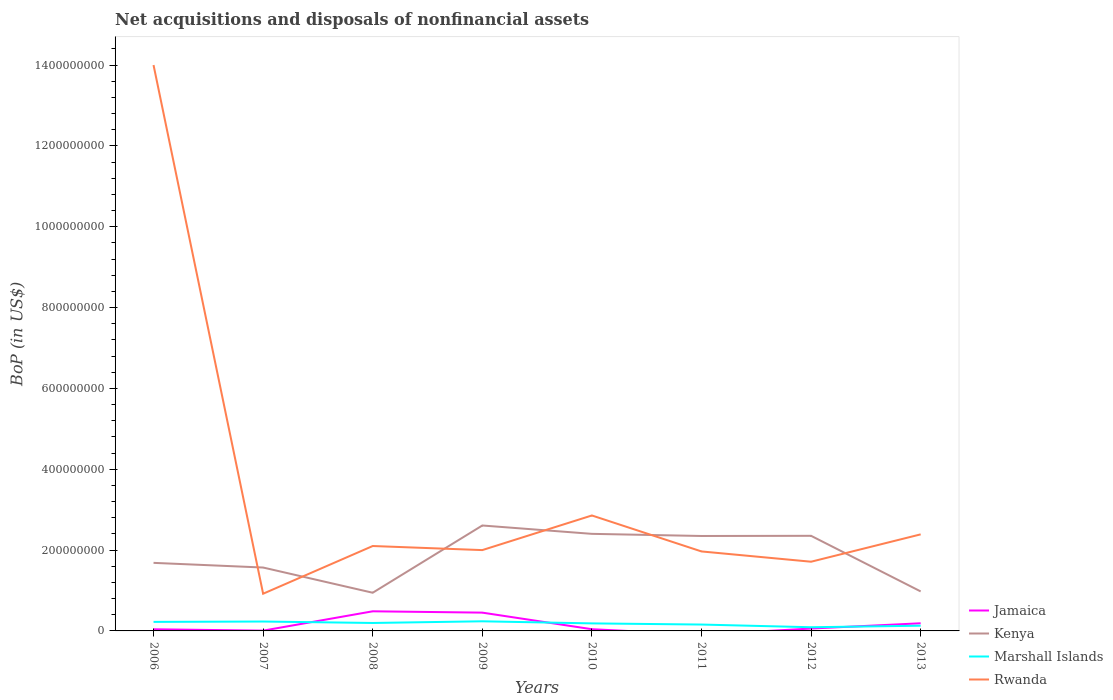How many different coloured lines are there?
Provide a succinct answer. 4. Is the number of lines equal to the number of legend labels?
Provide a succinct answer. No. Across all years, what is the maximum Balance of Payments in Marshall Islands?
Your response must be concise. 9.14e+06. What is the total Balance of Payments in Jamaica in the graph?
Keep it short and to the point. -4.12e+07. What is the difference between the highest and the second highest Balance of Payments in Kenya?
Your response must be concise. 1.66e+08. What is the difference between the highest and the lowest Balance of Payments in Jamaica?
Your answer should be compact. 3. Is the Balance of Payments in Marshall Islands strictly greater than the Balance of Payments in Rwanda over the years?
Keep it short and to the point. Yes. Are the values on the major ticks of Y-axis written in scientific E-notation?
Keep it short and to the point. No. Does the graph contain grids?
Your response must be concise. No. Where does the legend appear in the graph?
Provide a succinct answer. Bottom right. How many legend labels are there?
Offer a very short reply. 4. What is the title of the graph?
Make the answer very short. Net acquisitions and disposals of nonfinancial assets. What is the label or title of the X-axis?
Give a very brief answer. Years. What is the label or title of the Y-axis?
Your answer should be compact. BoP (in US$). What is the BoP (in US$) in Jamaica in 2006?
Your answer should be compact. 4.09e+06. What is the BoP (in US$) in Kenya in 2006?
Make the answer very short. 1.68e+08. What is the BoP (in US$) in Marshall Islands in 2006?
Your response must be concise. 2.23e+07. What is the BoP (in US$) in Rwanda in 2006?
Provide a short and direct response. 1.40e+09. What is the BoP (in US$) of Jamaica in 2007?
Provide a short and direct response. 6.90e+05. What is the BoP (in US$) in Kenya in 2007?
Your response must be concise. 1.57e+08. What is the BoP (in US$) of Marshall Islands in 2007?
Provide a short and direct response. 2.32e+07. What is the BoP (in US$) of Rwanda in 2007?
Offer a very short reply. 9.20e+07. What is the BoP (in US$) of Jamaica in 2008?
Your answer should be compact. 4.86e+07. What is the BoP (in US$) in Kenya in 2008?
Your answer should be very brief. 9.45e+07. What is the BoP (in US$) of Marshall Islands in 2008?
Your response must be concise. 1.97e+07. What is the BoP (in US$) in Rwanda in 2008?
Your answer should be very brief. 2.10e+08. What is the BoP (in US$) of Jamaica in 2009?
Your answer should be compact. 4.53e+07. What is the BoP (in US$) of Kenya in 2009?
Offer a terse response. 2.61e+08. What is the BoP (in US$) in Marshall Islands in 2009?
Provide a short and direct response. 2.38e+07. What is the BoP (in US$) in Rwanda in 2009?
Your response must be concise. 2.00e+08. What is the BoP (in US$) of Jamaica in 2010?
Make the answer very short. 4.24e+06. What is the BoP (in US$) in Kenya in 2010?
Offer a terse response. 2.40e+08. What is the BoP (in US$) of Marshall Islands in 2010?
Give a very brief answer. 1.86e+07. What is the BoP (in US$) of Rwanda in 2010?
Provide a succinct answer. 2.86e+08. What is the BoP (in US$) in Jamaica in 2011?
Your response must be concise. 0. What is the BoP (in US$) of Kenya in 2011?
Provide a succinct answer. 2.35e+08. What is the BoP (in US$) of Marshall Islands in 2011?
Make the answer very short. 1.58e+07. What is the BoP (in US$) in Rwanda in 2011?
Provide a short and direct response. 1.97e+08. What is the BoP (in US$) in Jamaica in 2012?
Ensure brevity in your answer.  5.87e+06. What is the BoP (in US$) in Kenya in 2012?
Offer a very short reply. 2.35e+08. What is the BoP (in US$) in Marshall Islands in 2012?
Give a very brief answer. 9.14e+06. What is the BoP (in US$) of Rwanda in 2012?
Provide a succinct answer. 1.71e+08. What is the BoP (in US$) in Jamaica in 2013?
Ensure brevity in your answer.  1.89e+07. What is the BoP (in US$) of Kenya in 2013?
Your response must be concise. 9.77e+07. What is the BoP (in US$) of Marshall Islands in 2013?
Provide a short and direct response. 1.29e+07. What is the BoP (in US$) of Rwanda in 2013?
Ensure brevity in your answer.  2.39e+08. Across all years, what is the maximum BoP (in US$) in Jamaica?
Your answer should be compact. 4.86e+07. Across all years, what is the maximum BoP (in US$) in Kenya?
Provide a short and direct response. 2.61e+08. Across all years, what is the maximum BoP (in US$) in Marshall Islands?
Provide a short and direct response. 2.38e+07. Across all years, what is the maximum BoP (in US$) in Rwanda?
Your answer should be compact. 1.40e+09. Across all years, what is the minimum BoP (in US$) in Kenya?
Provide a short and direct response. 9.45e+07. Across all years, what is the minimum BoP (in US$) of Marshall Islands?
Ensure brevity in your answer.  9.14e+06. Across all years, what is the minimum BoP (in US$) in Rwanda?
Ensure brevity in your answer.  9.20e+07. What is the total BoP (in US$) of Jamaica in the graph?
Give a very brief answer. 1.28e+08. What is the total BoP (in US$) in Kenya in the graph?
Ensure brevity in your answer.  1.49e+09. What is the total BoP (in US$) of Marshall Islands in the graph?
Make the answer very short. 1.46e+08. What is the total BoP (in US$) of Rwanda in the graph?
Your answer should be very brief. 2.79e+09. What is the difference between the BoP (in US$) of Jamaica in 2006 and that in 2007?
Offer a terse response. 3.40e+06. What is the difference between the BoP (in US$) in Kenya in 2006 and that in 2007?
Offer a very short reply. 1.16e+07. What is the difference between the BoP (in US$) in Marshall Islands in 2006 and that in 2007?
Offer a very short reply. -9.06e+05. What is the difference between the BoP (in US$) in Rwanda in 2006 and that in 2007?
Make the answer very short. 1.31e+09. What is the difference between the BoP (in US$) of Jamaica in 2006 and that in 2008?
Provide a succinct answer. -4.45e+07. What is the difference between the BoP (in US$) of Kenya in 2006 and that in 2008?
Offer a terse response. 7.39e+07. What is the difference between the BoP (in US$) of Marshall Islands in 2006 and that in 2008?
Provide a succinct answer. 2.67e+06. What is the difference between the BoP (in US$) of Rwanda in 2006 and that in 2008?
Provide a succinct answer. 1.19e+09. What is the difference between the BoP (in US$) in Jamaica in 2006 and that in 2009?
Make the answer very short. -4.12e+07. What is the difference between the BoP (in US$) in Kenya in 2006 and that in 2009?
Offer a terse response. -9.25e+07. What is the difference between the BoP (in US$) in Marshall Islands in 2006 and that in 2009?
Your answer should be very brief. -1.47e+06. What is the difference between the BoP (in US$) in Rwanda in 2006 and that in 2009?
Give a very brief answer. 1.20e+09. What is the difference between the BoP (in US$) of Jamaica in 2006 and that in 2010?
Your response must be concise. -1.52e+05. What is the difference between the BoP (in US$) of Kenya in 2006 and that in 2010?
Give a very brief answer. -7.18e+07. What is the difference between the BoP (in US$) in Marshall Islands in 2006 and that in 2010?
Provide a short and direct response. 3.70e+06. What is the difference between the BoP (in US$) of Rwanda in 2006 and that in 2010?
Give a very brief answer. 1.11e+09. What is the difference between the BoP (in US$) in Kenya in 2006 and that in 2011?
Provide a short and direct response. -6.65e+07. What is the difference between the BoP (in US$) in Marshall Islands in 2006 and that in 2011?
Offer a very short reply. 6.58e+06. What is the difference between the BoP (in US$) in Rwanda in 2006 and that in 2011?
Ensure brevity in your answer.  1.20e+09. What is the difference between the BoP (in US$) in Jamaica in 2006 and that in 2012?
Offer a very short reply. -1.78e+06. What is the difference between the BoP (in US$) in Kenya in 2006 and that in 2012?
Keep it short and to the point. -6.69e+07. What is the difference between the BoP (in US$) in Marshall Islands in 2006 and that in 2012?
Make the answer very short. 1.32e+07. What is the difference between the BoP (in US$) in Rwanda in 2006 and that in 2012?
Give a very brief answer. 1.23e+09. What is the difference between the BoP (in US$) in Jamaica in 2006 and that in 2013?
Make the answer very short. -1.48e+07. What is the difference between the BoP (in US$) of Kenya in 2006 and that in 2013?
Provide a short and direct response. 7.07e+07. What is the difference between the BoP (in US$) of Marshall Islands in 2006 and that in 2013?
Offer a terse response. 9.43e+06. What is the difference between the BoP (in US$) of Rwanda in 2006 and that in 2013?
Your answer should be very brief. 1.16e+09. What is the difference between the BoP (in US$) in Jamaica in 2007 and that in 2008?
Your response must be concise. -4.79e+07. What is the difference between the BoP (in US$) in Kenya in 2007 and that in 2008?
Ensure brevity in your answer.  6.24e+07. What is the difference between the BoP (in US$) in Marshall Islands in 2007 and that in 2008?
Keep it short and to the point. 3.57e+06. What is the difference between the BoP (in US$) in Rwanda in 2007 and that in 2008?
Your response must be concise. -1.18e+08. What is the difference between the BoP (in US$) of Jamaica in 2007 and that in 2009?
Provide a short and direct response. -4.46e+07. What is the difference between the BoP (in US$) of Kenya in 2007 and that in 2009?
Your response must be concise. -1.04e+08. What is the difference between the BoP (in US$) in Marshall Islands in 2007 and that in 2009?
Your response must be concise. -5.65e+05. What is the difference between the BoP (in US$) of Rwanda in 2007 and that in 2009?
Your answer should be very brief. -1.08e+08. What is the difference between the BoP (in US$) in Jamaica in 2007 and that in 2010?
Your answer should be compact. -3.55e+06. What is the difference between the BoP (in US$) in Kenya in 2007 and that in 2010?
Your answer should be very brief. -8.33e+07. What is the difference between the BoP (in US$) in Marshall Islands in 2007 and that in 2010?
Offer a very short reply. 4.61e+06. What is the difference between the BoP (in US$) of Rwanda in 2007 and that in 2010?
Offer a terse response. -1.94e+08. What is the difference between the BoP (in US$) of Kenya in 2007 and that in 2011?
Keep it short and to the point. -7.81e+07. What is the difference between the BoP (in US$) in Marshall Islands in 2007 and that in 2011?
Your response must be concise. 7.48e+06. What is the difference between the BoP (in US$) in Rwanda in 2007 and that in 2011?
Ensure brevity in your answer.  -1.05e+08. What is the difference between the BoP (in US$) in Jamaica in 2007 and that in 2012?
Your answer should be compact. -5.18e+06. What is the difference between the BoP (in US$) of Kenya in 2007 and that in 2012?
Make the answer very short. -7.85e+07. What is the difference between the BoP (in US$) of Marshall Islands in 2007 and that in 2012?
Provide a short and direct response. 1.41e+07. What is the difference between the BoP (in US$) of Rwanda in 2007 and that in 2012?
Offer a very short reply. -7.92e+07. What is the difference between the BoP (in US$) of Jamaica in 2007 and that in 2013?
Ensure brevity in your answer.  -1.82e+07. What is the difference between the BoP (in US$) in Kenya in 2007 and that in 2013?
Your answer should be compact. 5.91e+07. What is the difference between the BoP (in US$) in Marshall Islands in 2007 and that in 2013?
Provide a short and direct response. 1.03e+07. What is the difference between the BoP (in US$) of Rwanda in 2007 and that in 2013?
Your response must be concise. -1.47e+08. What is the difference between the BoP (in US$) of Jamaica in 2008 and that in 2009?
Offer a very short reply. 3.31e+06. What is the difference between the BoP (in US$) of Kenya in 2008 and that in 2009?
Your response must be concise. -1.66e+08. What is the difference between the BoP (in US$) in Marshall Islands in 2008 and that in 2009?
Ensure brevity in your answer.  -4.14e+06. What is the difference between the BoP (in US$) in Rwanda in 2008 and that in 2009?
Ensure brevity in your answer.  1.01e+07. What is the difference between the BoP (in US$) of Jamaica in 2008 and that in 2010?
Ensure brevity in your answer.  4.43e+07. What is the difference between the BoP (in US$) of Kenya in 2008 and that in 2010?
Your answer should be compact. -1.46e+08. What is the difference between the BoP (in US$) of Marshall Islands in 2008 and that in 2010?
Give a very brief answer. 1.04e+06. What is the difference between the BoP (in US$) in Rwanda in 2008 and that in 2010?
Make the answer very short. -7.56e+07. What is the difference between the BoP (in US$) of Kenya in 2008 and that in 2011?
Keep it short and to the point. -1.40e+08. What is the difference between the BoP (in US$) in Marshall Islands in 2008 and that in 2011?
Provide a short and direct response. 3.91e+06. What is the difference between the BoP (in US$) of Rwanda in 2008 and that in 2011?
Your answer should be very brief. 1.34e+07. What is the difference between the BoP (in US$) in Jamaica in 2008 and that in 2012?
Your answer should be very brief. 4.27e+07. What is the difference between the BoP (in US$) of Kenya in 2008 and that in 2012?
Your answer should be compact. -1.41e+08. What is the difference between the BoP (in US$) of Marshall Islands in 2008 and that in 2012?
Provide a succinct answer. 1.05e+07. What is the difference between the BoP (in US$) in Rwanda in 2008 and that in 2012?
Your response must be concise. 3.88e+07. What is the difference between the BoP (in US$) of Jamaica in 2008 and that in 2013?
Provide a short and direct response. 2.97e+07. What is the difference between the BoP (in US$) in Kenya in 2008 and that in 2013?
Offer a terse response. -3.26e+06. What is the difference between the BoP (in US$) in Marshall Islands in 2008 and that in 2013?
Give a very brief answer. 6.76e+06. What is the difference between the BoP (in US$) in Rwanda in 2008 and that in 2013?
Ensure brevity in your answer.  -2.89e+07. What is the difference between the BoP (in US$) of Jamaica in 2009 and that in 2010?
Offer a very short reply. 4.10e+07. What is the difference between the BoP (in US$) of Kenya in 2009 and that in 2010?
Offer a terse response. 2.07e+07. What is the difference between the BoP (in US$) of Marshall Islands in 2009 and that in 2010?
Your answer should be very brief. 5.17e+06. What is the difference between the BoP (in US$) in Rwanda in 2009 and that in 2010?
Provide a short and direct response. -8.56e+07. What is the difference between the BoP (in US$) of Kenya in 2009 and that in 2011?
Your response must be concise. 2.60e+07. What is the difference between the BoP (in US$) of Marshall Islands in 2009 and that in 2011?
Provide a short and direct response. 8.05e+06. What is the difference between the BoP (in US$) in Rwanda in 2009 and that in 2011?
Offer a very short reply. 3.34e+06. What is the difference between the BoP (in US$) of Jamaica in 2009 and that in 2012?
Offer a terse response. 3.94e+07. What is the difference between the BoP (in US$) of Kenya in 2009 and that in 2012?
Keep it short and to the point. 2.56e+07. What is the difference between the BoP (in US$) in Marshall Islands in 2009 and that in 2012?
Keep it short and to the point. 1.47e+07. What is the difference between the BoP (in US$) in Rwanda in 2009 and that in 2012?
Offer a very short reply. 2.88e+07. What is the difference between the BoP (in US$) in Jamaica in 2009 and that in 2013?
Provide a short and direct response. 2.64e+07. What is the difference between the BoP (in US$) of Kenya in 2009 and that in 2013?
Offer a terse response. 1.63e+08. What is the difference between the BoP (in US$) of Marshall Islands in 2009 and that in 2013?
Keep it short and to the point. 1.09e+07. What is the difference between the BoP (in US$) in Rwanda in 2009 and that in 2013?
Provide a succinct answer. -3.89e+07. What is the difference between the BoP (in US$) in Kenya in 2010 and that in 2011?
Give a very brief answer. 5.29e+06. What is the difference between the BoP (in US$) of Marshall Islands in 2010 and that in 2011?
Provide a short and direct response. 2.88e+06. What is the difference between the BoP (in US$) in Rwanda in 2010 and that in 2011?
Make the answer very short. 8.90e+07. What is the difference between the BoP (in US$) of Jamaica in 2010 and that in 2012?
Give a very brief answer. -1.63e+06. What is the difference between the BoP (in US$) in Kenya in 2010 and that in 2012?
Your response must be concise. 4.88e+06. What is the difference between the BoP (in US$) of Marshall Islands in 2010 and that in 2012?
Ensure brevity in your answer.  9.50e+06. What is the difference between the BoP (in US$) of Rwanda in 2010 and that in 2012?
Keep it short and to the point. 1.14e+08. What is the difference between the BoP (in US$) of Jamaica in 2010 and that in 2013?
Give a very brief answer. -1.47e+07. What is the difference between the BoP (in US$) in Kenya in 2010 and that in 2013?
Give a very brief answer. 1.42e+08. What is the difference between the BoP (in US$) of Marshall Islands in 2010 and that in 2013?
Your answer should be very brief. 5.73e+06. What is the difference between the BoP (in US$) of Rwanda in 2010 and that in 2013?
Your response must be concise. 4.67e+07. What is the difference between the BoP (in US$) in Kenya in 2011 and that in 2012?
Give a very brief answer. -4.11e+05. What is the difference between the BoP (in US$) of Marshall Islands in 2011 and that in 2012?
Provide a short and direct response. 6.62e+06. What is the difference between the BoP (in US$) of Rwanda in 2011 and that in 2012?
Keep it short and to the point. 2.54e+07. What is the difference between the BoP (in US$) in Kenya in 2011 and that in 2013?
Your answer should be compact. 1.37e+08. What is the difference between the BoP (in US$) in Marshall Islands in 2011 and that in 2013?
Keep it short and to the point. 2.85e+06. What is the difference between the BoP (in US$) in Rwanda in 2011 and that in 2013?
Provide a succinct answer. -4.23e+07. What is the difference between the BoP (in US$) of Jamaica in 2012 and that in 2013?
Keep it short and to the point. -1.30e+07. What is the difference between the BoP (in US$) of Kenya in 2012 and that in 2013?
Provide a succinct answer. 1.38e+08. What is the difference between the BoP (in US$) in Marshall Islands in 2012 and that in 2013?
Your answer should be compact. -3.77e+06. What is the difference between the BoP (in US$) of Rwanda in 2012 and that in 2013?
Provide a short and direct response. -6.77e+07. What is the difference between the BoP (in US$) of Jamaica in 2006 and the BoP (in US$) of Kenya in 2007?
Your answer should be very brief. -1.53e+08. What is the difference between the BoP (in US$) of Jamaica in 2006 and the BoP (in US$) of Marshall Islands in 2007?
Ensure brevity in your answer.  -1.92e+07. What is the difference between the BoP (in US$) in Jamaica in 2006 and the BoP (in US$) in Rwanda in 2007?
Your response must be concise. -8.79e+07. What is the difference between the BoP (in US$) of Kenya in 2006 and the BoP (in US$) of Marshall Islands in 2007?
Ensure brevity in your answer.  1.45e+08. What is the difference between the BoP (in US$) of Kenya in 2006 and the BoP (in US$) of Rwanda in 2007?
Your answer should be compact. 7.64e+07. What is the difference between the BoP (in US$) in Marshall Islands in 2006 and the BoP (in US$) in Rwanda in 2007?
Ensure brevity in your answer.  -6.97e+07. What is the difference between the BoP (in US$) in Jamaica in 2006 and the BoP (in US$) in Kenya in 2008?
Make the answer very short. -9.04e+07. What is the difference between the BoP (in US$) of Jamaica in 2006 and the BoP (in US$) of Marshall Islands in 2008?
Offer a very short reply. -1.56e+07. What is the difference between the BoP (in US$) of Jamaica in 2006 and the BoP (in US$) of Rwanda in 2008?
Provide a succinct answer. -2.06e+08. What is the difference between the BoP (in US$) of Kenya in 2006 and the BoP (in US$) of Marshall Islands in 2008?
Keep it short and to the point. 1.49e+08. What is the difference between the BoP (in US$) in Kenya in 2006 and the BoP (in US$) in Rwanda in 2008?
Offer a very short reply. -4.17e+07. What is the difference between the BoP (in US$) in Marshall Islands in 2006 and the BoP (in US$) in Rwanda in 2008?
Keep it short and to the point. -1.88e+08. What is the difference between the BoP (in US$) in Jamaica in 2006 and the BoP (in US$) in Kenya in 2009?
Offer a very short reply. -2.57e+08. What is the difference between the BoP (in US$) of Jamaica in 2006 and the BoP (in US$) of Marshall Islands in 2009?
Ensure brevity in your answer.  -1.97e+07. What is the difference between the BoP (in US$) in Jamaica in 2006 and the BoP (in US$) in Rwanda in 2009?
Provide a short and direct response. -1.96e+08. What is the difference between the BoP (in US$) in Kenya in 2006 and the BoP (in US$) in Marshall Islands in 2009?
Make the answer very short. 1.45e+08. What is the difference between the BoP (in US$) in Kenya in 2006 and the BoP (in US$) in Rwanda in 2009?
Your response must be concise. -3.16e+07. What is the difference between the BoP (in US$) of Marshall Islands in 2006 and the BoP (in US$) of Rwanda in 2009?
Offer a terse response. -1.78e+08. What is the difference between the BoP (in US$) in Jamaica in 2006 and the BoP (in US$) in Kenya in 2010?
Your answer should be very brief. -2.36e+08. What is the difference between the BoP (in US$) in Jamaica in 2006 and the BoP (in US$) in Marshall Islands in 2010?
Your response must be concise. -1.45e+07. What is the difference between the BoP (in US$) of Jamaica in 2006 and the BoP (in US$) of Rwanda in 2010?
Offer a terse response. -2.82e+08. What is the difference between the BoP (in US$) in Kenya in 2006 and the BoP (in US$) in Marshall Islands in 2010?
Your answer should be very brief. 1.50e+08. What is the difference between the BoP (in US$) of Kenya in 2006 and the BoP (in US$) of Rwanda in 2010?
Provide a short and direct response. -1.17e+08. What is the difference between the BoP (in US$) in Marshall Islands in 2006 and the BoP (in US$) in Rwanda in 2010?
Provide a short and direct response. -2.63e+08. What is the difference between the BoP (in US$) of Jamaica in 2006 and the BoP (in US$) of Kenya in 2011?
Give a very brief answer. -2.31e+08. What is the difference between the BoP (in US$) in Jamaica in 2006 and the BoP (in US$) in Marshall Islands in 2011?
Keep it short and to the point. -1.17e+07. What is the difference between the BoP (in US$) of Jamaica in 2006 and the BoP (in US$) of Rwanda in 2011?
Your answer should be compact. -1.93e+08. What is the difference between the BoP (in US$) in Kenya in 2006 and the BoP (in US$) in Marshall Islands in 2011?
Offer a terse response. 1.53e+08. What is the difference between the BoP (in US$) of Kenya in 2006 and the BoP (in US$) of Rwanda in 2011?
Offer a very short reply. -2.83e+07. What is the difference between the BoP (in US$) of Marshall Islands in 2006 and the BoP (in US$) of Rwanda in 2011?
Provide a succinct answer. -1.74e+08. What is the difference between the BoP (in US$) of Jamaica in 2006 and the BoP (in US$) of Kenya in 2012?
Give a very brief answer. -2.31e+08. What is the difference between the BoP (in US$) of Jamaica in 2006 and the BoP (in US$) of Marshall Islands in 2012?
Provide a short and direct response. -5.05e+06. What is the difference between the BoP (in US$) in Jamaica in 2006 and the BoP (in US$) in Rwanda in 2012?
Offer a terse response. -1.67e+08. What is the difference between the BoP (in US$) in Kenya in 2006 and the BoP (in US$) in Marshall Islands in 2012?
Offer a very short reply. 1.59e+08. What is the difference between the BoP (in US$) in Kenya in 2006 and the BoP (in US$) in Rwanda in 2012?
Give a very brief answer. -2.82e+06. What is the difference between the BoP (in US$) in Marshall Islands in 2006 and the BoP (in US$) in Rwanda in 2012?
Offer a terse response. -1.49e+08. What is the difference between the BoP (in US$) in Jamaica in 2006 and the BoP (in US$) in Kenya in 2013?
Offer a terse response. -9.36e+07. What is the difference between the BoP (in US$) of Jamaica in 2006 and the BoP (in US$) of Marshall Islands in 2013?
Keep it short and to the point. -8.82e+06. What is the difference between the BoP (in US$) of Jamaica in 2006 and the BoP (in US$) of Rwanda in 2013?
Give a very brief answer. -2.35e+08. What is the difference between the BoP (in US$) in Kenya in 2006 and the BoP (in US$) in Marshall Islands in 2013?
Offer a very short reply. 1.55e+08. What is the difference between the BoP (in US$) in Kenya in 2006 and the BoP (in US$) in Rwanda in 2013?
Ensure brevity in your answer.  -7.05e+07. What is the difference between the BoP (in US$) of Marshall Islands in 2006 and the BoP (in US$) of Rwanda in 2013?
Your answer should be compact. -2.17e+08. What is the difference between the BoP (in US$) in Jamaica in 2007 and the BoP (in US$) in Kenya in 2008?
Give a very brief answer. -9.38e+07. What is the difference between the BoP (in US$) of Jamaica in 2007 and the BoP (in US$) of Marshall Islands in 2008?
Ensure brevity in your answer.  -1.90e+07. What is the difference between the BoP (in US$) of Jamaica in 2007 and the BoP (in US$) of Rwanda in 2008?
Your response must be concise. -2.09e+08. What is the difference between the BoP (in US$) in Kenya in 2007 and the BoP (in US$) in Marshall Islands in 2008?
Your answer should be very brief. 1.37e+08. What is the difference between the BoP (in US$) of Kenya in 2007 and the BoP (in US$) of Rwanda in 2008?
Your answer should be compact. -5.32e+07. What is the difference between the BoP (in US$) of Marshall Islands in 2007 and the BoP (in US$) of Rwanda in 2008?
Ensure brevity in your answer.  -1.87e+08. What is the difference between the BoP (in US$) in Jamaica in 2007 and the BoP (in US$) in Kenya in 2009?
Your answer should be very brief. -2.60e+08. What is the difference between the BoP (in US$) in Jamaica in 2007 and the BoP (in US$) in Marshall Islands in 2009?
Give a very brief answer. -2.31e+07. What is the difference between the BoP (in US$) of Jamaica in 2007 and the BoP (in US$) of Rwanda in 2009?
Provide a succinct answer. -1.99e+08. What is the difference between the BoP (in US$) of Kenya in 2007 and the BoP (in US$) of Marshall Islands in 2009?
Offer a terse response. 1.33e+08. What is the difference between the BoP (in US$) of Kenya in 2007 and the BoP (in US$) of Rwanda in 2009?
Keep it short and to the point. -4.32e+07. What is the difference between the BoP (in US$) of Marshall Islands in 2007 and the BoP (in US$) of Rwanda in 2009?
Provide a succinct answer. -1.77e+08. What is the difference between the BoP (in US$) of Jamaica in 2007 and the BoP (in US$) of Kenya in 2010?
Make the answer very short. -2.39e+08. What is the difference between the BoP (in US$) of Jamaica in 2007 and the BoP (in US$) of Marshall Islands in 2010?
Offer a very short reply. -1.79e+07. What is the difference between the BoP (in US$) in Jamaica in 2007 and the BoP (in US$) in Rwanda in 2010?
Keep it short and to the point. -2.85e+08. What is the difference between the BoP (in US$) in Kenya in 2007 and the BoP (in US$) in Marshall Islands in 2010?
Offer a very short reply. 1.38e+08. What is the difference between the BoP (in US$) in Kenya in 2007 and the BoP (in US$) in Rwanda in 2010?
Provide a short and direct response. -1.29e+08. What is the difference between the BoP (in US$) of Marshall Islands in 2007 and the BoP (in US$) of Rwanda in 2010?
Your answer should be compact. -2.62e+08. What is the difference between the BoP (in US$) of Jamaica in 2007 and the BoP (in US$) of Kenya in 2011?
Make the answer very short. -2.34e+08. What is the difference between the BoP (in US$) in Jamaica in 2007 and the BoP (in US$) in Marshall Islands in 2011?
Your answer should be compact. -1.51e+07. What is the difference between the BoP (in US$) in Jamaica in 2007 and the BoP (in US$) in Rwanda in 2011?
Provide a short and direct response. -1.96e+08. What is the difference between the BoP (in US$) of Kenya in 2007 and the BoP (in US$) of Marshall Islands in 2011?
Keep it short and to the point. 1.41e+08. What is the difference between the BoP (in US$) of Kenya in 2007 and the BoP (in US$) of Rwanda in 2011?
Make the answer very short. -3.98e+07. What is the difference between the BoP (in US$) of Marshall Islands in 2007 and the BoP (in US$) of Rwanda in 2011?
Your answer should be very brief. -1.73e+08. What is the difference between the BoP (in US$) of Jamaica in 2007 and the BoP (in US$) of Kenya in 2012?
Keep it short and to the point. -2.35e+08. What is the difference between the BoP (in US$) of Jamaica in 2007 and the BoP (in US$) of Marshall Islands in 2012?
Your answer should be compact. -8.45e+06. What is the difference between the BoP (in US$) in Jamaica in 2007 and the BoP (in US$) in Rwanda in 2012?
Ensure brevity in your answer.  -1.71e+08. What is the difference between the BoP (in US$) in Kenya in 2007 and the BoP (in US$) in Marshall Islands in 2012?
Your response must be concise. 1.48e+08. What is the difference between the BoP (in US$) in Kenya in 2007 and the BoP (in US$) in Rwanda in 2012?
Offer a very short reply. -1.44e+07. What is the difference between the BoP (in US$) of Marshall Islands in 2007 and the BoP (in US$) of Rwanda in 2012?
Offer a terse response. -1.48e+08. What is the difference between the BoP (in US$) of Jamaica in 2007 and the BoP (in US$) of Kenya in 2013?
Make the answer very short. -9.70e+07. What is the difference between the BoP (in US$) in Jamaica in 2007 and the BoP (in US$) in Marshall Islands in 2013?
Your response must be concise. -1.22e+07. What is the difference between the BoP (in US$) in Jamaica in 2007 and the BoP (in US$) in Rwanda in 2013?
Offer a terse response. -2.38e+08. What is the difference between the BoP (in US$) of Kenya in 2007 and the BoP (in US$) of Marshall Islands in 2013?
Keep it short and to the point. 1.44e+08. What is the difference between the BoP (in US$) in Kenya in 2007 and the BoP (in US$) in Rwanda in 2013?
Make the answer very short. -8.21e+07. What is the difference between the BoP (in US$) of Marshall Islands in 2007 and the BoP (in US$) of Rwanda in 2013?
Your answer should be very brief. -2.16e+08. What is the difference between the BoP (in US$) in Jamaica in 2008 and the BoP (in US$) in Kenya in 2009?
Ensure brevity in your answer.  -2.12e+08. What is the difference between the BoP (in US$) of Jamaica in 2008 and the BoP (in US$) of Marshall Islands in 2009?
Give a very brief answer. 2.48e+07. What is the difference between the BoP (in US$) of Jamaica in 2008 and the BoP (in US$) of Rwanda in 2009?
Keep it short and to the point. -1.51e+08. What is the difference between the BoP (in US$) in Kenya in 2008 and the BoP (in US$) in Marshall Islands in 2009?
Your answer should be very brief. 7.07e+07. What is the difference between the BoP (in US$) of Kenya in 2008 and the BoP (in US$) of Rwanda in 2009?
Offer a terse response. -1.06e+08. What is the difference between the BoP (in US$) in Marshall Islands in 2008 and the BoP (in US$) in Rwanda in 2009?
Offer a very short reply. -1.80e+08. What is the difference between the BoP (in US$) in Jamaica in 2008 and the BoP (in US$) in Kenya in 2010?
Provide a short and direct response. -1.92e+08. What is the difference between the BoP (in US$) of Jamaica in 2008 and the BoP (in US$) of Marshall Islands in 2010?
Provide a short and direct response. 2.99e+07. What is the difference between the BoP (in US$) of Jamaica in 2008 and the BoP (in US$) of Rwanda in 2010?
Keep it short and to the point. -2.37e+08. What is the difference between the BoP (in US$) in Kenya in 2008 and the BoP (in US$) in Marshall Islands in 2010?
Make the answer very short. 7.58e+07. What is the difference between the BoP (in US$) in Kenya in 2008 and the BoP (in US$) in Rwanda in 2010?
Give a very brief answer. -1.91e+08. What is the difference between the BoP (in US$) of Marshall Islands in 2008 and the BoP (in US$) of Rwanda in 2010?
Keep it short and to the point. -2.66e+08. What is the difference between the BoP (in US$) of Jamaica in 2008 and the BoP (in US$) of Kenya in 2011?
Your answer should be compact. -1.86e+08. What is the difference between the BoP (in US$) of Jamaica in 2008 and the BoP (in US$) of Marshall Islands in 2011?
Give a very brief answer. 3.28e+07. What is the difference between the BoP (in US$) of Jamaica in 2008 and the BoP (in US$) of Rwanda in 2011?
Make the answer very short. -1.48e+08. What is the difference between the BoP (in US$) in Kenya in 2008 and the BoP (in US$) in Marshall Islands in 2011?
Your answer should be compact. 7.87e+07. What is the difference between the BoP (in US$) of Kenya in 2008 and the BoP (in US$) of Rwanda in 2011?
Your response must be concise. -1.02e+08. What is the difference between the BoP (in US$) in Marshall Islands in 2008 and the BoP (in US$) in Rwanda in 2011?
Your answer should be very brief. -1.77e+08. What is the difference between the BoP (in US$) of Jamaica in 2008 and the BoP (in US$) of Kenya in 2012?
Offer a very short reply. -1.87e+08. What is the difference between the BoP (in US$) in Jamaica in 2008 and the BoP (in US$) in Marshall Islands in 2012?
Provide a succinct answer. 3.94e+07. What is the difference between the BoP (in US$) of Jamaica in 2008 and the BoP (in US$) of Rwanda in 2012?
Make the answer very short. -1.23e+08. What is the difference between the BoP (in US$) of Kenya in 2008 and the BoP (in US$) of Marshall Islands in 2012?
Keep it short and to the point. 8.53e+07. What is the difference between the BoP (in US$) of Kenya in 2008 and the BoP (in US$) of Rwanda in 2012?
Offer a terse response. -7.67e+07. What is the difference between the BoP (in US$) in Marshall Islands in 2008 and the BoP (in US$) in Rwanda in 2012?
Provide a succinct answer. -1.52e+08. What is the difference between the BoP (in US$) of Jamaica in 2008 and the BoP (in US$) of Kenya in 2013?
Give a very brief answer. -4.92e+07. What is the difference between the BoP (in US$) in Jamaica in 2008 and the BoP (in US$) in Marshall Islands in 2013?
Give a very brief answer. 3.57e+07. What is the difference between the BoP (in US$) in Jamaica in 2008 and the BoP (in US$) in Rwanda in 2013?
Provide a short and direct response. -1.90e+08. What is the difference between the BoP (in US$) of Kenya in 2008 and the BoP (in US$) of Marshall Islands in 2013?
Offer a terse response. 8.16e+07. What is the difference between the BoP (in US$) in Kenya in 2008 and the BoP (in US$) in Rwanda in 2013?
Your answer should be compact. -1.44e+08. What is the difference between the BoP (in US$) of Marshall Islands in 2008 and the BoP (in US$) of Rwanda in 2013?
Keep it short and to the point. -2.19e+08. What is the difference between the BoP (in US$) in Jamaica in 2009 and the BoP (in US$) in Kenya in 2010?
Ensure brevity in your answer.  -1.95e+08. What is the difference between the BoP (in US$) in Jamaica in 2009 and the BoP (in US$) in Marshall Islands in 2010?
Provide a succinct answer. 2.66e+07. What is the difference between the BoP (in US$) in Jamaica in 2009 and the BoP (in US$) in Rwanda in 2010?
Make the answer very short. -2.40e+08. What is the difference between the BoP (in US$) of Kenya in 2009 and the BoP (in US$) of Marshall Islands in 2010?
Offer a very short reply. 2.42e+08. What is the difference between the BoP (in US$) of Kenya in 2009 and the BoP (in US$) of Rwanda in 2010?
Make the answer very short. -2.48e+07. What is the difference between the BoP (in US$) in Marshall Islands in 2009 and the BoP (in US$) in Rwanda in 2010?
Your response must be concise. -2.62e+08. What is the difference between the BoP (in US$) of Jamaica in 2009 and the BoP (in US$) of Kenya in 2011?
Your answer should be compact. -1.90e+08. What is the difference between the BoP (in US$) of Jamaica in 2009 and the BoP (in US$) of Marshall Islands in 2011?
Offer a very short reply. 2.95e+07. What is the difference between the BoP (in US$) in Jamaica in 2009 and the BoP (in US$) in Rwanda in 2011?
Your answer should be very brief. -1.51e+08. What is the difference between the BoP (in US$) in Kenya in 2009 and the BoP (in US$) in Marshall Islands in 2011?
Give a very brief answer. 2.45e+08. What is the difference between the BoP (in US$) of Kenya in 2009 and the BoP (in US$) of Rwanda in 2011?
Your answer should be compact. 6.42e+07. What is the difference between the BoP (in US$) of Marshall Islands in 2009 and the BoP (in US$) of Rwanda in 2011?
Your response must be concise. -1.73e+08. What is the difference between the BoP (in US$) of Jamaica in 2009 and the BoP (in US$) of Kenya in 2012?
Your answer should be very brief. -1.90e+08. What is the difference between the BoP (in US$) in Jamaica in 2009 and the BoP (in US$) in Marshall Islands in 2012?
Offer a very short reply. 3.61e+07. What is the difference between the BoP (in US$) of Jamaica in 2009 and the BoP (in US$) of Rwanda in 2012?
Make the answer very short. -1.26e+08. What is the difference between the BoP (in US$) in Kenya in 2009 and the BoP (in US$) in Marshall Islands in 2012?
Your answer should be compact. 2.52e+08. What is the difference between the BoP (in US$) in Kenya in 2009 and the BoP (in US$) in Rwanda in 2012?
Make the answer very short. 8.96e+07. What is the difference between the BoP (in US$) of Marshall Islands in 2009 and the BoP (in US$) of Rwanda in 2012?
Make the answer very short. -1.47e+08. What is the difference between the BoP (in US$) of Jamaica in 2009 and the BoP (in US$) of Kenya in 2013?
Ensure brevity in your answer.  -5.25e+07. What is the difference between the BoP (in US$) in Jamaica in 2009 and the BoP (in US$) in Marshall Islands in 2013?
Offer a very short reply. 3.23e+07. What is the difference between the BoP (in US$) in Jamaica in 2009 and the BoP (in US$) in Rwanda in 2013?
Offer a very short reply. -1.94e+08. What is the difference between the BoP (in US$) of Kenya in 2009 and the BoP (in US$) of Marshall Islands in 2013?
Ensure brevity in your answer.  2.48e+08. What is the difference between the BoP (in US$) in Kenya in 2009 and the BoP (in US$) in Rwanda in 2013?
Give a very brief answer. 2.19e+07. What is the difference between the BoP (in US$) in Marshall Islands in 2009 and the BoP (in US$) in Rwanda in 2013?
Your answer should be compact. -2.15e+08. What is the difference between the BoP (in US$) of Jamaica in 2010 and the BoP (in US$) of Kenya in 2011?
Give a very brief answer. -2.31e+08. What is the difference between the BoP (in US$) of Jamaica in 2010 and the BoP (in US$) of Marshall Islands in 2011?
Your answer should be very brief. -1.15e+07. What is the difference between the BoP (in US$) in Jamaica in 2010 and the BoP (in US$) in Rwanda in 2011?
Give a very brief answer. -1.92e+08. What is the difference between the BoP (in US$) in Kenya in 2010 and the BoP (in US$) in Marshall Islands in 2011?
Ensure brevity in your answer.  2.24e+08. What is the difference between the BoP (in US$) of Kenya in 2010 and the BoP (in US$) of Rwanda in 2011?
Offer a terse response. 4.35e+07. What is the difference between the BoP (in US$) in Marshall Islands in 2010 and the BoP (in US$) in Rwanda in 2011?
Offer a terse response. -1.78e+08. What is the difference between the BoP (in US$) in Jamaica in 2010 and the BoP (in US$) in Kenya in 2012?
Offer a very short reply. -2.31e+08. What is the difference between the BoP (in US$) in Jamaica in 2010 and the BoP (in US$) in Marshall Islands in 2012?
Offer a terse response. -4.90e+06. What is the difference between the BoP (in US$) in Jamaica in 2010 and the BoP (in US$) in Rwanda in 2012?
Your response must be concise. -1.67e+08. What is the difference between the BoP (in US$) in Kenya in 2010 and the BoP (in US$) in Marshall Islands in 2012?
Provide a succinct answer. 2.31e+08. What is the difference between the BoP (in US$) of Kenya in 2010 and the BoP (in US$) of Rwanda in 2012?
Your answer should be compact. 6.90e+07. What is the difference between the BoP (in US$) in Marshall Islands in 2010 and the BoP (in US$) in Rwanda in 2012?
Offer a terse response. -1.53e+08. What is the difference between the BoP (in US$) of Jamaica in 2010 and the BoP (in US$) of Kenya in 2013?
Keep it short and to the point. -9.35e+07. What is the difference between the BoP (in US$) of Jamaica in 2010 and the BoP (in US$) of Marshall Islands in 2013?
Your response must be concise. -8.67e+06. What is the difference between the BoP (in US$) in Jamaica in 2010 and the BoP (in US$) in Rwanda in 2013?
Ensure brevity in your answer.  -2.35e+08. What is the difference between the BoP (in US$) of Kenya in 2010 and the BoP (in US$) of Marshall Islands in 2013?
Your answer should be very brief. 2.27e+08. What is the difference between the BoP (in US$) in Kenya in 2010 and the BoP (in US$) in Rwanda in 2013?
Your answer should be compact. 1.25e+06. What is the difference between the BoP (in US$) in Marshall Islands in 2010 and the BoP (in US$) in Rwanda in 2013?
Your response must be concise. -2.20e+08. What is the difference between the BoP (in US$) of Kenya in 2011 and the BoP (in US$) of Marshall Islands in 2012?
Offer a very short reply. 2.26e+08. What is the difference between the BoP (in US$) of Kenya in 2011 and the BoP (in US$) of Rwanda in 2012?
Provide a short and direct response. 6.37e+07. What is the difference between the BoP (in US$) in Marshall Islands in 2011 and the BoP (in US$) in Rwanda in 2012?
Give a very brief answer. -1.55e+08. What is the difference between the BoP (in US$) in Kenya in 2011 and the BoP (in US$) in Marshall Islands in 2013?
Ensure brevity in your answer.  2.22e+08. What is the difference between the BoP (in US$) of Kenya in 2011 and the BoP (in US$) of Rwanda in 2013?
Ensure brevity in your answer.  -4.04e+06. What is the difference between the BoP (in US$) of Marshall Islands in 2011 and the BoP (in US$) of Rwanda in 2013?
Offer a terse response. -2.23e+08. What is the difference between the BoP (in US$) of Jamaica in 2012 and the BoP (in US$) of Kenya in 2013?
Provide a succinct answer. -9.19e+07. What is the difference between the BoP (in US$) in Jamaica in 2012 and the BoP (in US$) in Marshall Islands in 2013?
Offer a terse response. -7.04e+06. What is the difference between the BoP (in US$) in Jamaica in 2012 and the BoP (in US$) in Rwanda in 2013?
Provide a short and direct response. -2.33e+08. What is the difference between the BoP (in US$) in Kenya in 2012 and the BoP (in US$) in Marshall Islands in 2013?
Give a very brief answer. 2.22e+08. What is the difference between the BoP (in US$) of Kenya in 2012 and the BoP (in US$) of Rwanda in 2013?
Your answer should be very brief. -3.63e+06. What is the difference between the BoP (in US$) in Marshall Islands in 2012 and the BoP (in US$) in Rwanda in 2013?
Offer a terse response. -2.30e+08. What is the average BoP (in US$) in Jamaica per year?
Make the answer very short. 1.60e+07. What is the average BoP (in US$) of Kenya per year?
Your answer should be compact. 1.86e+08. What is the average BoP (in US$) of Marshall Islands per year?
Your answer should be compact. 1.82e+07. What is the average BoP (in US$) of Rwanda per year?
Provide a succinct answer. 3.49e+08. In the year 2006, what is the difference between the BoP (in US$) in Jamaica and BoP (in US$) in Kenya?
Offer a terse response. -1.64e+08. In the year 2006, what is the difference between the BoP (in US$) in Jamaica and BoP (in US$) in Marshall Islands?
Give a very brief answer. -1.82e+07. In the year 2006, what is the difference between the BoP (in US$) of Jamaica and BoP (in US$) of Rwanda?
Your answer should be very brief. -1.40e+09. In the year 2006, what is the difference between the BoP (in US$) in Kenya and BoP (in US$) in Marshall Islands?
Offer a terse response. 1.46e+08. In the year 2006, what is the difference between the BoP (in US$) in Kenya and BoP (in US$) in Rwanda?
Keep it short and to the point. -1.23e+09. In the year 2006, what is the difference between the BoP (in US$) of Marshall Islands and BoP (in US$) of Rwanda?
Provide a succinct answer. -1.38e+09. In the year 2007, what is the difference between the BoP (in US$) in Jamaica and BoP (in US$) in Kenya?
Your response must be concise. -1.56e+08. In the year 2007, what is the difference between the BoP (in US$) of Jamaica and BoP (in US$) of Marshall Islands?
Make the answer very short. -2.26e+07. In the year 2007, what is the difference between the BoP (in US$) of Jamaica and BoP (in US$) of Rwanda?
Your response must be concise. -9.13e+07. In the year 2007, what is the difference between the BoP (in US$) of Kenya and BoP (in US$) of Marshall Islands?
Your answer should be very brief. 1.34e+08. In the year 2007, what is the difference between the BoP (in US$) in Kenya and BoP (in US$) in Rwanda?
Provide a succinct answer. 6.48e+07. In the year 2007, what is the difference between the BoP (in US$) of Marshall Islands and BoP (in US$) of Rwanda?
Keep it short and to the point. -6.88e+07. In the year 2008, what is the difference between the BoP (in US$) in Jamaica and BoP (in US$) in Kenya?
Your answer should be very brief. -4.59e+07. In the year 2008, what is the difference between the BoP (in US$) of Jamaica and BoP (in US$) of Marshall Islands?
Your answer should be compact. 2.89e+07. In the year 2008, what is the difference between the BoP (in US$) of Jamaica and BoP (in US$) of Rwanda?
Your answer should be compact. -1.61e+08. In the year 2008, what is the difference between the BoP (in US$) of Kenya and BoP (in US$) of Marshall Islands?
Offer a terse response. 7.48e+07. In the year 2008, what is the difference between the BoP (in US$) of Kenya and BoP (in US$) of Rwanda?
Your answer should be compact. -1.16e+08. In the year 2008, what is the difference between the BoP (in US$) in Marshall Islands and BoP (in US$) in Rwanda?
Give a very brief answer. -1.90e+08. In the year 2009, what is the difference between the BoP (in US$) in Jamaica and BoP (in US$) in Kenya?
Offer a very short reply. -2.16e+08. In the year 2009, what is the difference between the BoP (in US$) in Jamaica and BoP (in US$) in Marshall Islands?
Ensure brevity in your answer.  2.14e+07. In the year 2009, what is the difference between the BoP (in US$) in Jamaica and BoP (in US$) in Rwanda?
Make the answer very short. -1.55e+08. In the year 2009, what is the difference between the BoP (in US$) in Kenya and BoP (in US$) in Marshall Islands?
Give a very brief answer. 2.37e+08. In the year 2009, what is the difference between the BoP (in US$) in Kenya and BoP (in US$) in Rwanda?
Make the answer very short. 6.09e+07. In the year 2009, what is the difference between the BoP (in US$) in Marshall Islands and BoP (in US$) in Rwanda?
Give a very brief answer. -1.76e+08. In the year 2010, what is the difference between the BoP (in US$) in Jamaica and BoP (in US$) in Kenya?
Keep it short and to the point. -2.36e+08. In the year 2010, what is the difference between the BoP (in US$) in Jamaica and BoP (in US$) in Marshall Islands?
Make the answer very short. -1.44e+07. In the year 2010, what is the difference between the BoP (in US$) of Jamaica and BoP (in US$) of Rwanda?
Give a very brief answer. -2.81e+08. In the year 2010, what is the difference between the BoP (in US$) in Kenya and BoP (in US$) in Marshall Islands?
Keep it short and to the point. 2.22e+08. In the year 2010, what is the difference between the BoP (in US$) in Kenya and BoP (in US$) in Rwanda?
Your response must be concise. -4.55e+07. In the year 2010, what is the difference between the BoP (in US$) in Marshall Islands and BoP (in US$) in Rwanda?
Ensure brevity in your answer.  -2.67e+08. In the year 2011, what is the difference between the BoP (in US$) in Kenya and BoP (in US$) in Marshall Islands?
Your answer should be very brief. 2.19e+08. In the year 2011, what is the difference between the BoP (in US$) of Kenya and BoP (in US$) of Rwanda?
Give a very brief answer. 3.82e+07. In the year 2011, what is the difference between the BoP (in US$) of Marshall Islands and BoP (in US$) of Rwanda?
Make the answer very short. -1.81e+08. In the year 2012, what is the difference between the BoP (in US$) in Jamaica and BoP (in US$) in Kenya?
Make the answer very short. -2.29e+08. In the year 2012, what is the difference between the BoP (in US$) of Jamaica and BoP (in US$) of Marshall Islands?
Provide a succinct answer. -3.27e+06. In the year 2012, what is the difference between the BoP (in US$) in Jamaica and BoP (in US$) in Rwanda?
Make the answer very short. -1.65e+08. In the year 2012, what is the difference between the BoP (in US$) of Kenya and BoP (in US$) of Marshall Islands?
Ensure brevity in your answer.  2.26e+08. In the year 2012, what is the difference between the BoP (in US$) of Kenya and BoP (in US$) of Rwanda?
Your answer should be very brief. 6.41e+07. In the year 2012, what is the difference between the BoP (in US$) of Marshall Islands and BoP (in US$) of Rwanda?
Your answer should be very brief. -1.62e+08. In the year 2013, what is the difference between the BoP (in US$) of Jamaica and BoP (in US$) of Kenya?
Provide a short and direct response. -7.88e+07. In the year 2013, what is the difference between the BoP (in US$) in Jamaica and BoP (in US$) in Marshall Islands?
Provide a short and direct response. 5.99e+06. In the year 2013, what is the difference between the BoP (in US$) of Jamaica and BoP (in US$) of Rwanda?
Give a very brief answer. -2.20e+08. In the year 2013, what is the difference between the BoP (in US$) of Kenya and BoP (in US$) of Marshall Islands?
Ensure brevity in your answer.  8.48e+07. In the year 2013, what is the difference between the BoP (in US$) in Kenya and BoP (in US$) in Rwanda?
Your answer should be very brief. -1.41e+08. In the year 2013, what is the difference between the BoP (in US$) in Marshall Islands and BoP (in US$) in Rwanda?
Make the answer very short. -2.26e+08. What is the ratio of the BoP (in US$) of Jamaica in 2006 to that in 2007?
Offer a terse response. 5.93. What is the ratio of the BoP (in US$) of Kenya in 2006 to that in 2007?
Your answer should be compact. 1.07. What is the ratio of the BoP (in US$) in Rwanda in 2006 to that in 2007?
Make the answer very short. 15.21. What is the ratio of the BoP (in US$) in Jamaica in 2006 to that in 2008?
Ensure brevity in your answer.  0.08. What is the ratio of the BoP (in US$) in Kenya in 2006 to that in 2008?
Your response must be concise. 1.78. What is the ratio of the BoP (in US$) in Marshall Islands in 2006 to that in 2008?
Your answer should be compact. 1.14. What is the ratio of the BoP (in US$) in Rwanda in 2006 to that in 2008?
Your response must be concise. 6.67. What is the ratio of the BoP (in US$) in Jamaica in 2006 to that in 2009?
Provide a short and direct response. 0.09. What is the ratio of the BoP (in US$) in Kenya in 2006 to that in 2009?
Provide a short and direct response. 0.65. What is the ratio of the BoP (in US$) in Marshall Islands in 2006 to that in 2009?
Provide a succinct answer. 0.94. What is the ratio of the BoP (in US$) of Rwanda in 2006 to that in 2009?
Offer a very short reply. 7. What is the ratio of the BoP (in US$) of Jamaica in 2006 to that in 2010?
Ensure brevity in your answer.  0.96. What is the ratio of the BoP (in US$) of Kenya in 2006 to that in 2010?
Keep it short and to the point. 0.7. What is the ratio of the BoP (in US$) of Marshall Islands in 2006 to that in 2010?
Provide a short and direct response. 1.2. What is the ratio of the BoP (in US$) of Rwanda in 2006 to that in 2010?
Your answer should be very brief. 4.9. What is the ratio of the BoP (in US$) of Kenya in 2006 to that in 2011?
Offer a very short reply. 0.72. What is the ratio of the BoP (in US$) of Marshall Islands in 2006 to that in 2011?
Make the answer very short. 1.42. What is the ratio of the BoP (in US$) in Rwanda in 2006 to that in 2011?
Offer a very short reply. 7.12. What is the ratio of the BoP (in US$) in Jamaica in 2006 to that in 2012?
Make the answer very short. 0.7. What is the ratio of the BoP (in US$) in Kenya in 2006 to that in 2012?
Your answer should be compact. 0.72. What is the ratio of the BoP (in US$) of Marshall Islands in 2006 to that in 2012?
Your answer should be very brief. 2.44. What is the ratio of the BoP (in US$) in Rwanda in 2006 to that in 2012?
Provide a succinct answer. 8.18. What is the ratio of the BoP (in US$) in Jamaica in 2006 to that in 2013?
Offer a very short reply. 0.22. What is the ratio of the BoP (in US$) in Kenya in 2006 to that in 2013?
Your response must be concise. 1.72. What is the ratio of the BoP (in US$) of Marshall Islands in 2006 to that in 2013?
Ensure brevity in your answer.  1.73. What is the ratio of the BoP (in US$) in Rwanda in 2006 to that in 2013?
Provide a succinct answer. 5.86. What is the ratio of the BoP (in US$) in Jamaica in 2007 to that in 2008?
Provide a succinct answer. 0.01. What is the ratio of the BoP (in US$) of Kenya in 2007 to that in 2008?
Your response must be concise. 1.66. What is the ratio of the BoP (in US$) in Marshall Islands in 2007 to that in 2008?
Your response must be concise. 1.18. What is the ratio of the BoP (in US$) in Rwanda in 2007 to that in 2008?
Offer a terse response. 0.44. What is the ratio of the BoP (in US$) of Jamaica in 2007 to that in 2009?
Your answer should be very brief. 0.02. What is the ratio of the BoP (in US$) in Kenya in 2007 to that in 2009?
Offer a very short reply. 0.6. What is the ratio of the BoP (in US$) of Marshall Islands in 2007 to that in 2009?
Give a very brief answer. 0.98. What is the ratio of the BoP (in US$) in Rwanda in 2007 to that in 2009?
Your answer should be compact. 0.46. What is the ratio of the BoP (in US$) of Jamaica in 2007 to that in 2010?
Provide a short and direct response. 0.16. What is the ratio of the BoP (in US$) of Kenya in 2007 to that in 2010?
Provide a succinct answer. 0.65. What is the ratio of the BoP (in US$) of Marshall Islands in 2007 to that in 2010?
Keep it short and to the point. 1.25. What is the ratio of the BoP (in US$) of Rwanda in 2007 to that in 2010?
Ensure brevity in your answer.  0.32. What is the ratio of the BoP (in US$) of Kenya in 2007 to that in 2011?
Your answer should be compact. 0.67. What is the ratio of the BoP (in US$) in Marshall Islands in 2007 to that in 2011?
Provide a succinct answer. 1.47. What is the ratio of the BoP (in US$) in Rwanda in 2007 to that in 2011?
Ensure brevity in your answer.  0.47. What is the ratio of the BoP (in US$) in Jamaica in 2007 to that in 2012?
Offer a terse response. 0.12. What is the ratio of the BoP (in US$) in Kenya in 2007 to that in 2012?
Provide a succinct answer. 0.67. What is the ratio of the BoP (in US$) of Marshall Islands in 2007 to that in 2012?
Make the answer very short. 2.54. What is the ratio of the BoP (in US$) in Rwanda in 2007 to that in 2012?
Make the answer very short. 0.54. What is the ratio of the BoP (in US$) in Jamaica in 2007 to that in 2013?
Make the answer very short. 0.04. What is the ratio of the BoP (in US$) of Kenya in 2007 to that in 2013?
Give a very brief answer. 1.6. What is the ratio of the BoP (in US$) in Marshall Islands in 2007 to that in 2013?
Ensure brevity in your answer.  1.8. What is the ratio of the BoP (in US$) of Rwanda in 2007 to that in 2013?
Keep it short and to the point. 0.39. What is the ratio of the BoP (in US$) of Jamaica in 2008 to that in 2009?
Ensure brevity in your answer.  1.07. What is the ratio of the BoP (in US$) of Kenya in 2008 to that in 2009?
Provide a succinct answer. 0.36. What is the ratio of the BoP (in US$) in Marshall Islands in 2008 to that in 2009?
Provide a succinct answer. 0.83. What is the ratio of the BoP (in US$) in Rwanda in 2008 to that in 2009?
Give a very brief answer. 1.05. What is the ratio of the BoP (in US$) in Jamaica in 2008 to that in 2010?
Ensure brevity in your answer.  11.45. What is the ratio of the BoP (in US$) in Kenya in 2008 to that in 2010?
Your answer should be very brief. 0.39. What is the ratio of the BoP (in US$) in Marshall Islands in 2008 to that in 2010?
Give a very brief answer. 1.06. What is the ratio of the BoP (in US$) of Rwanda in 2008 to that in 2010?
Your answer should be compact. 0.74. What is the ratio of the BoP (in US$) in Kenya in 2008 to that in 2011?
Give a very brief answer. 0.4. What is the ratio of the BoP (in US$) of Marshall Islands in 2008 to that in 2011?
Your answer should be compact. 1.25. What is the ratio of the BoP (in US$) of Rwanda in 2008 to that in 2011?
Provide a succinct answer. 1.07. What is the ratio of the BoP (in US$) of Jamaica in 2008 to that in 2012?
Keep it short and to the point. 8.27. What is the ratio of the BoP (in US$) in Kenya in 2008 to that in 2012?
Make the answer very short. 0.4. What is the ratio of the BoP (in US$) of Marshall Islands in 2008 to that in 2012?
Your answer should be compact. 2.15. What is the ratio of the BoP (in US$) in Rwanda in 2008 to that in 2012?
Make the answer very short. 1.23. What is the ratio of the BoP (in US$) in Jamaica in 2008 to that in 2013?
Your answer should be compact. 2.57. What is the ratio of the BoP (in US$) of Kenya in 2008 to that in 2013?
Offer a terse response. 0.97. What is the ratio of the BoP (in US$) in Marshall Islands in 2008 to that in 2013?
Your response must be concise. 1.52. What is the ratio of the BoP (in US$) in Rwanda in 2008 to that in 2013?
Provide a short and direct response. 0.88. What is the ratio of the BoP (in US$) in Jamaica in 2009 to that in 2010?
Your answer should be compact. 10.67. What is the ratio of the BoP (in US$) of Kenya in 2009 to that in 2010?
Offer a very short reply. 1.09. What is the ratio of the BoP (in US$) in Marshall Islands in 2009 to that in 2010?
Offer a very short reply. 1.28. What is the ratio of the BoP (in US$) of Rwanda in 2009 to that in 2010?
Your answer should be compact. 0.7. What is the ratio of the BoP (in US$) of Kenya in 2009 to that in 2011?
Provide a succinct answer. 1.11. What is the ratio of the BoP (in US$) in Marshall Islands in 2009 to that in 2011?
Ensure brevity in your answer.  1.51. What is the ratio of the BoP (in US$) of Rwanda in 2009 to that in 2011?
Make the answer very short. 1.02. What is the ratio of the BoP (in US$) in Jamaica in 2009 to that in 2012?
Your response must be concise. 7.71. What is the ratio of the BoP (in US$) in Kenya in 2009 to that in 2012?
Keep it short and to the point. 1.11. What is the ratio of the BoP (in US$) in Marshall Islands in 2009 to that in 2012?
Offer a terse response. 2.6. What is the ratio of the BoP (in US$) in Rwanda in 2009 to that in 2012?
Give a very brief answer. 1.17. What is the ratio of the BoP (in US$) in Jamaica in 2009 to that in 2013?
Give a very brief answer. 2.39. What is the ratio of the BoP (in US$) in Kenya in 2009 to that in 2013?
Ensure brevity in your answer.  2.67. What is the ratio of the BoP (in US$) in Marshall Islands in 2009 to that in 2013?
Offer a terse response. 1.84. What is the ratio of the BoP (in US$) of Rwanda in 2009 to that in 2013?
Your response must be concise. 0.84. What is the ratio of the BoP (in US$) of Kenya in 2010 to that in 2011?
Offer a terse response. 1.02. What is the ratio of the BoP (in US$) in Marshall Islands in 2010 to that in 2011?
Make the answer very short. 1.18. What is the ratio of the BoP (in US$) in Rwanda in 2010 to that in 2011?
Your response must be concise. 1.45. What is the ratio of the BoP (in US$) of Jamaica in 2010 to that in 2012?
Keep it short and to the point. 0.72. What is the ratio of the BoP (in US$) in Kenya in 2010 to that in 2012?
Provide a short and direct response. 1.02. What is the ratio of the BoP (in US$) in Marshall Islands in 2010 to that in 2012?
Your response must be concise. 2.04. What is the ratio of the BoP (in US$) of Rwanda in 2010 to that in 2012?
Give a very brief answer. 1.67. What is the ratio of the BoP (in US$) in Jamaica in 2010 to that in 2013?
Ensure brevity in your answer.  0.22. What is the ratio of the BoP (in US$) in Kenya in 2010 to that in 2013?
Ensure brevity in your answer.  2.46. What is the ratio of the BoP (in US$) of Marshall Islands in 2010 to that in 2013?
Your response must be concise. 1.44. What is the ratio of the BoP (in US$) in Rwanda in 2010 to that in 2013?
Ensure brevity in your answer.  1.2. What is the ratio of the BoP (in US$) of Kenya in 2011 to that in 2012?
Offer a terse response. 1. What is the ratio of the BoP (in US$) of Marshall Islands in 2011 to that in 2012?
Keep it short and to the point. 1.72. What is the ratio of the BoP (in US$) of Rwanda in 2011 to that in 2012?
Your answer should be very brief. 1.15. What is the ratio of the BoP (in US$) of Kenya in 2011 to that in 2013?
Provide a short and direct response. 2.4. What is the ratio of the BoP (in US$) of Marshall Islands in 2011 to that in 2013?
Your answer should be very brief. 1.22. What is the ratio of the BoP (in US$) of Rwanda in 2011 to that in 2013?
Provide a short and direct response. 0.82. What is the ratio of the BoP (in US$) of Jamaica in 2012 to that in 2013?
Offer a very short reply. 0.31. What is the ratio of the BoP (in US$) of Kenya in 2012 to that in 2013?
Offer a very short reply. 2.41. What is the ratio of the BoP (in US$) in Marshall Islands in 2012 to that in 2013?
Your answer should be very brief. 0.71. What is the ratio of the BoP (in US$) of Rwanda in 2012 to that in 2013?
Provide a short and direct response. 0.72. What is the difference between the highest and the second highest BoP (in US$) in Jamaica?
Provide a short and direct response. 3.31e+06. What is the difference between the highest and the second highest BoP (in US$) of Kenya?
Give a very brief answer. 2.07e+07. What is the difference between the highest and the second highest BoP (in US$) of Marshall Islands?
Offer a terse response. 5.65e+05. What is the difference between the highest and the second highest BoP (in US$) in Rwanda?
Your response must be concise. 1.11e+09. What is the difference between the highest and the lowest BoP (in US$) in Jamaica?
Provide a short and direct response. 4.86e+07. What is the difference between the highest and the lowest BoP (in US$) in Kenya?
Offer a very short reply. 1.66e+08. What is the difference between the highest and the lowest BoP (in US$) in Marshall Islands?
Offer a terse response. 1.47e+07. What is the difference between the highest and the lowest BoP (in US$) in Rwanda?
Offer a very short reply. 1.31e+09. 